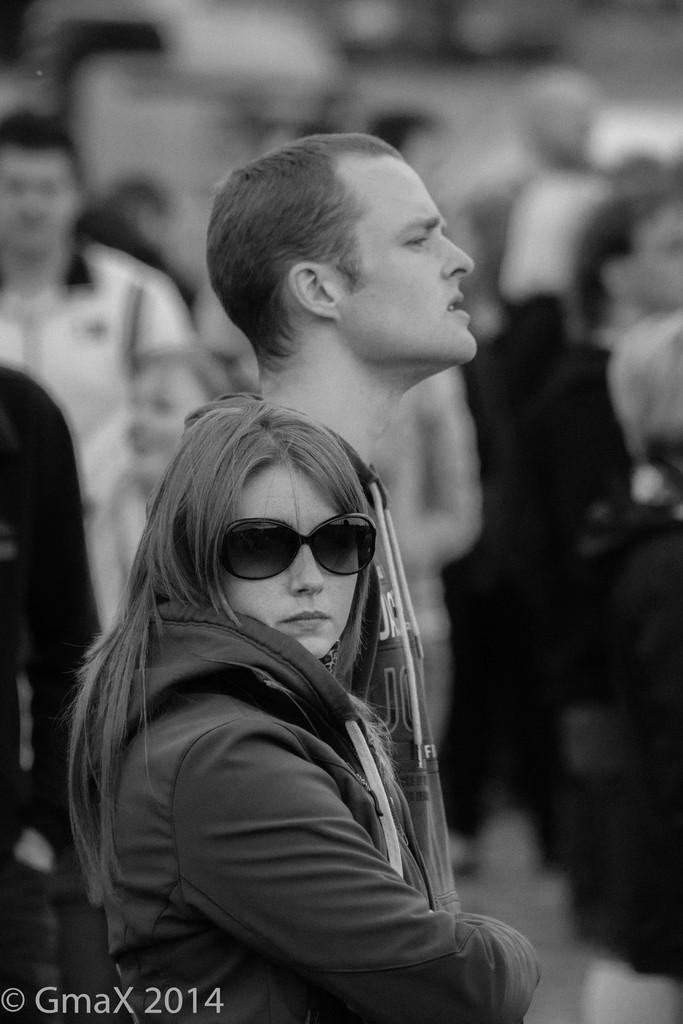In one or two sentences, can you explain what this image depicts? In the image we can see the black and white picture of people wearing clothes. On the bottom left, we can see the watermark and the background is blurred. 